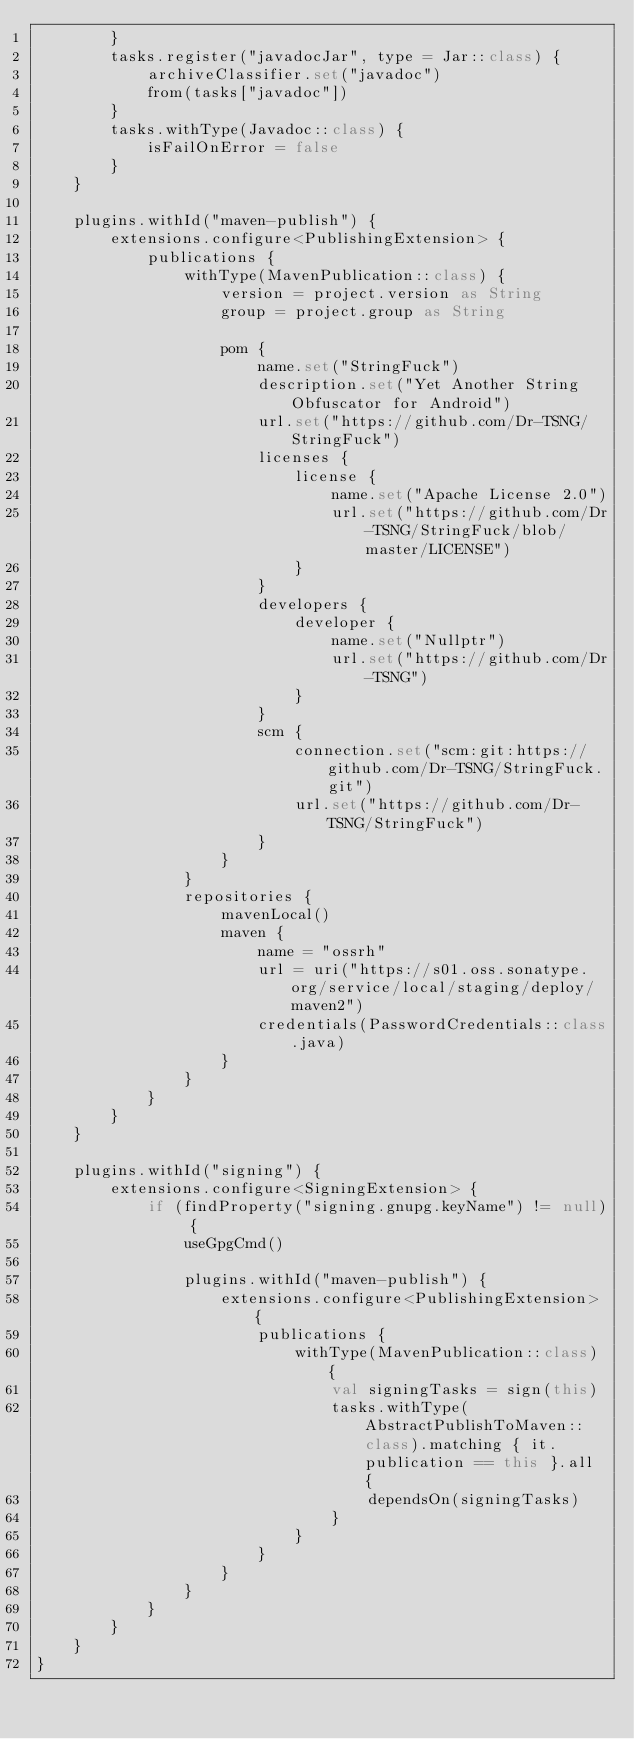Convert code to text. <code><loc_0><loc_0><loc_500><loc_500><_Kotlin_>        }
        tasks.register("javadocJar", type = Jar::class) {
            archiveClassifier.set("javadoc")
            from(tasks["javadoc"])
        }
        tasks.withType(Javadoc::class) {
            isFailOnError = false
        }
    }

    plugins.withId("maven-publish") {
        extensions.configure<PublishingExtension> {
            publications {
                withType(MavenPublication::class) {
                    version = project.version as String
                    group = project.group as String

                    pom {
                        name.set("StringFuck")
                        description.set("Yet Another String Obfuscator for Android")
                        url.set("https://github.com/Dr-TSNG/StringFuck")
                        licenses {
                            license {
                                name.set("Apache License 2.0")
                                url.set("https://github.com/Dr-TSNG/StringFuck/blob/master/LICENSE")
                            }
                        }
                        developers {
                            developer {
                                name.set("Nullptr")
                                url.set("https://github.com/Dr-TSNG")
                            }
                        }
                        scm {
                            connection.set("scm:git:https://github.com/Dr-TSNG/StringFuck.git")
                            url.set("https://github.com/Dr-TSNG/StringFuck")
                        }
                    }
                }
                repositories {
                    mavenLocal()
                    maven {
                        name = "ossrh"
                        url = uri("https://s01.oss.sonatype.org/service/local/staging/deploy/maven2")
                        credentials(PasswordCredentials::class.java)
                    }
                }
            }
        }
    }

    plugins.withId("signing") {
        extensions.configure<SigningExtension> {
            if (findProperty("signing.gnupg.keyName") != null) {
                useGpgCmd()

                plugins.withId("maven-publish") {
                    extensions.configure<PublishingExtension> {
                        publications {
                            withType(MavenPublication::class) {
                                val signingTasks = sign(this)
                                tasks.withType(AbstractPublishToMaven::class).matching { it.publication == this }.all {
                                    dependsOn(signingTasks)
                                }
                            }
                        }
                    }
                }
            }
        }
    }
}
</code> 